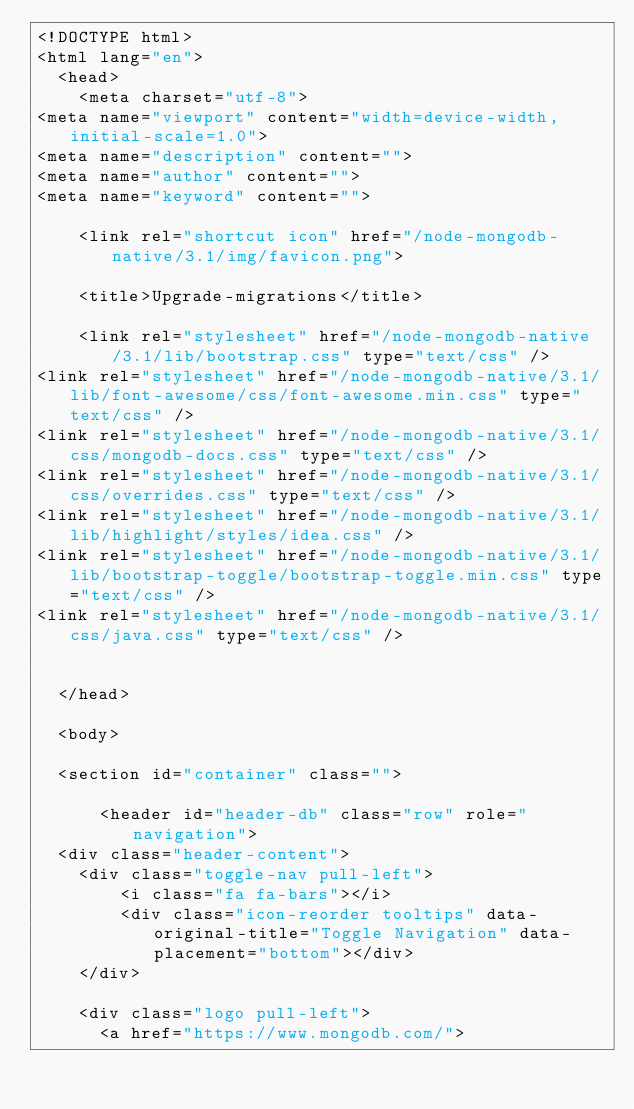Convert code to text. <code><loc_0><loc_0><loc_500><loc_500><_HTML_><!DOCTYPE html>
<html lang="en">
  <head>
    <meta charset="utf-8">
<meta name="viewport" content="width=device-width, initial-scale=1.0">
<meta name="description" content="">
<meta name="author" content="">
<meta name="keyword" content="">

    <link rel="shortcut icon" href="/node-mongodb-native/3.1/img/favicon.png">

    <title>Upgrade-migrations</title>

    <link rel="stylesheet" href="/node-mongodb-native/3.1/lib/bootstrap.css" type="text/css" />
<link rel="stylesheet" href="/node-mongodb-native/3.1/lib/font-awesome/css/font-awesome.min.css" type="text/css" />
<link rel="stylesheet" href="/node-mongodb-native/3.1/css/mongodb-docs.css" type="text/css" />
<link rel="stylesheet" href="/node-mongodb-native/3.1/css/overrides.css" type="text/css" />
<link rel="stylesheet" href="/node-mongodb-native/3.1/lib/highlight/styles/idea.css" />
<link rel="stylesheet" href="/node-mongodb-native/3.1/lib/bootstrap-toggle/bootstrap-toggle.min.css" type="text/css" />
<link rel="stylesheet" href="/node-mongodb-native/3.1/css/java.css" type="text/css" />


  </head>

  <body>
  
  <section id="container" class="">
      
      <header id="header-db" class="row" role="navigation">
  <div class="header-content">
    <div class="toggle-nav pull-left">
        <i class="fa fa-bars"></i>
        <div class="icon-reorder tooltips" data-original-title="Toggle Navigation" data-placement="bottom"></div>
    </div>
    
    <div class="logo pull-left">
      <a href="https://www.mongodb.com/"></code> 